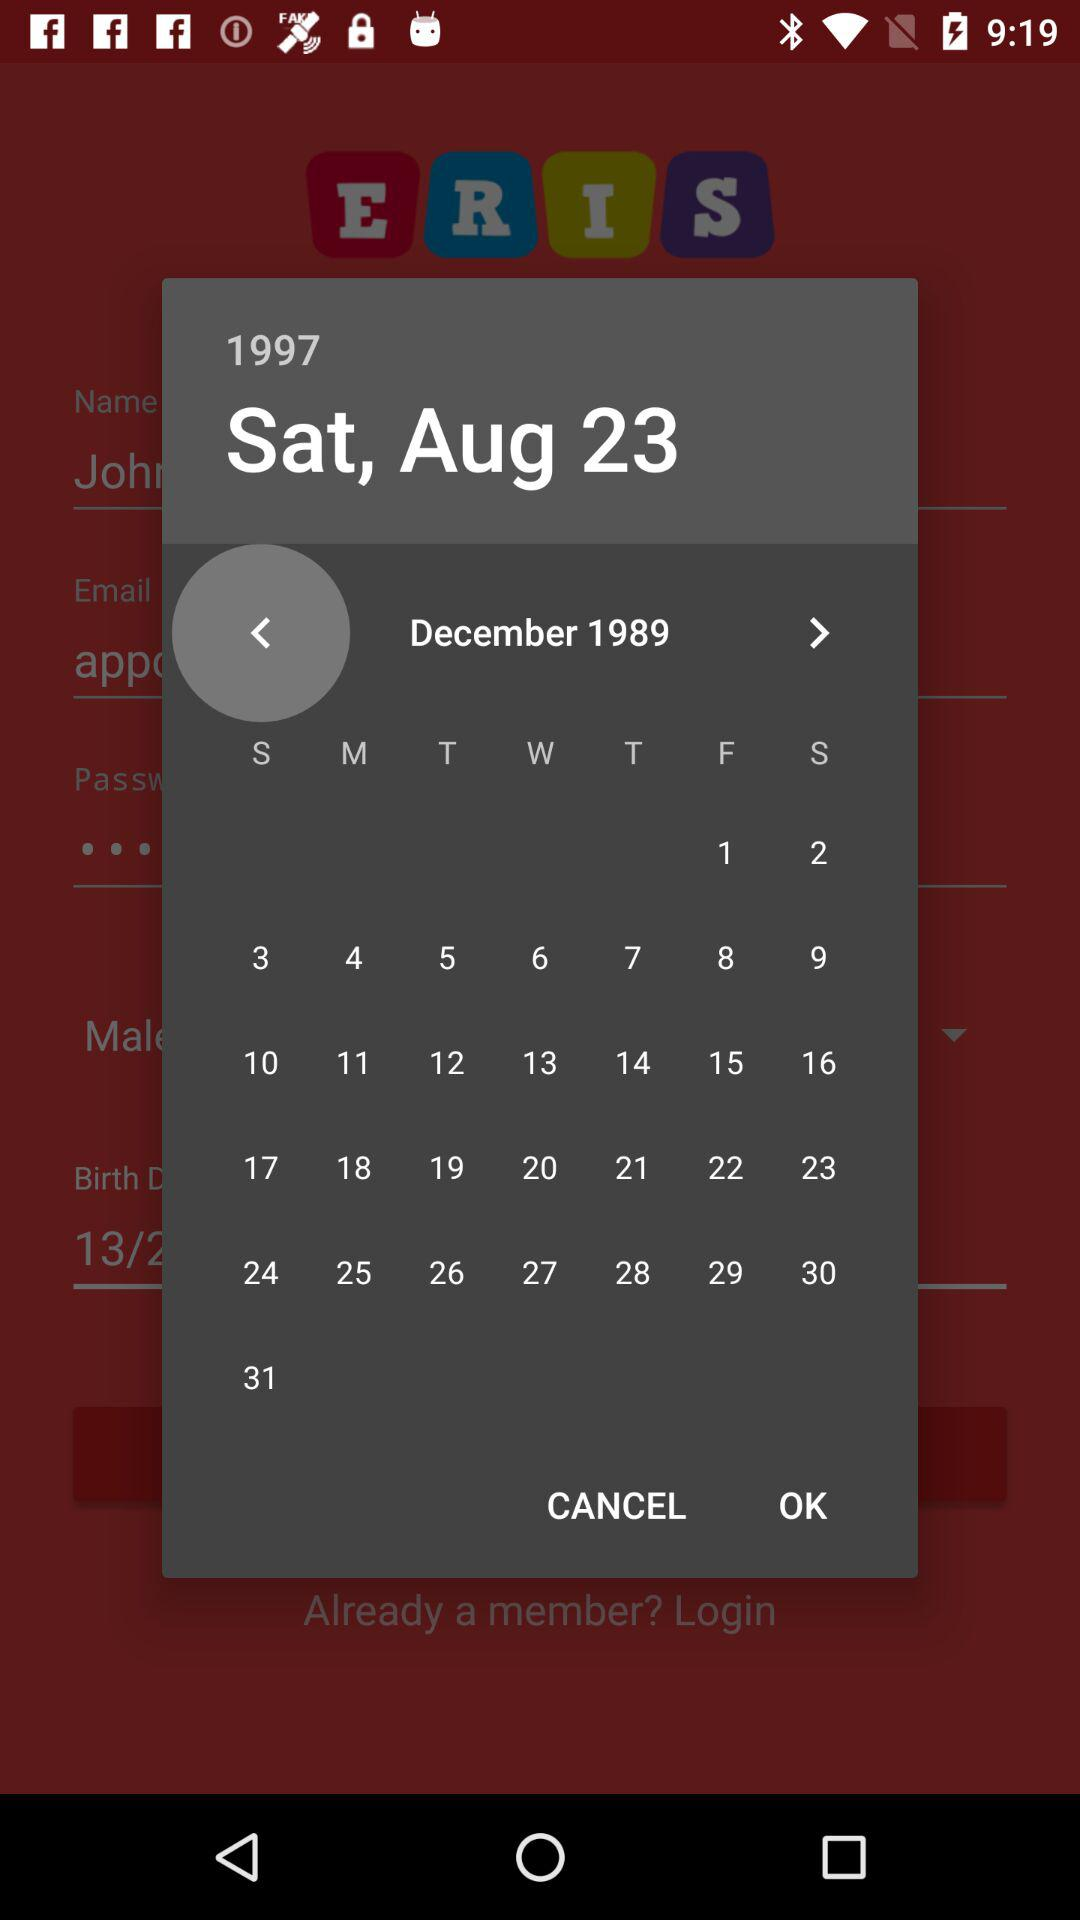What is the day that is selected? The day that is selected is Saturday. 